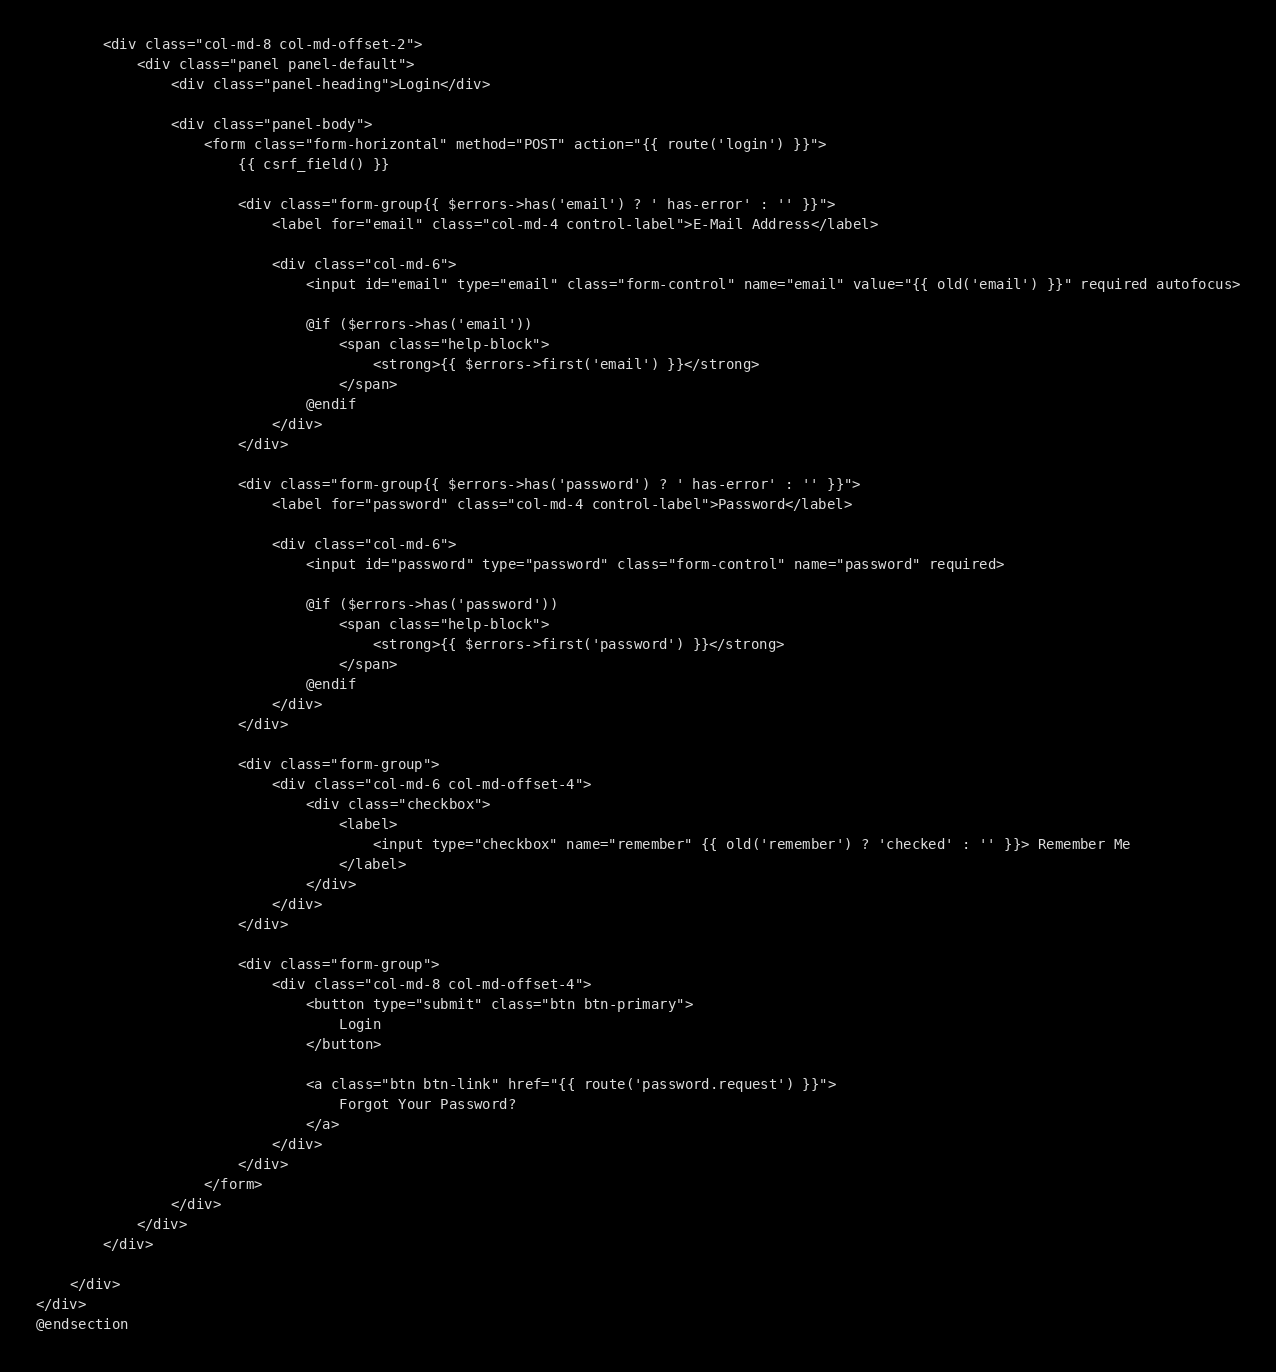Convert code to text. <code><loc_0><loc_0><loc_500><loc_500><_PHP_>        <div class="col-md-8 col-md-offset-2">
            <div class="panel panel-default">
                <div class="panel-heading">Login</div>

                <div class="panel-body">
                    <form class="form-horizontal" method="POST" action="{{ route('login') }}">
                        {{ csrf_field() }}

                        <div class="form-group{{ $errors->has('email') ? ' has-error' : '' }}">
                            <label for="email" class="col-md-4 control-label">E-Mail Address</label>

                            <div class="col-md-6">
                                <input id="email" type="email" class="form-control" name="email" value="{{ old('email') }}" required autofocus>

                                @if ($errors->has('email'))
                                    <span class="help-block">
                                        <strong>{{ $errors->first('email') }}</strong>
                                    </span>
                                @endif
                            </div>
                        </div>

                        <div class="form-group{{ $errors->has('password') ? ' has-error' : '' }}">
                            <label for="password" class="col-md-4 control-label">Password</label>

                            <div class="col-md-6">
                                <input id="password" type="password" class="form-control" name="password" required>

                                @if ($errors->has('password'))
                                    <span class="help-block">
                                        <strong>{{ $errors->first('password') }}</strong>
                                    </span>
                                @endif
                            </div>
                        </div>

                        <div class="form-group">
                            <div class="col-md-6 col-md-offset-4">
                                <div class="checkbox">
                                    <label>
                                        <input type="checkbox" name="remember" {{ old('remember') ? 'checked' : '' }}> Remember Me
                                    </label>
                                </div>
                            </div>
                        </div>

                        <div class="form-group">
                            <div class="col-md-8 col-md-offset-4">
                                <button type="submit" class="btn btn-primary">
                                    Login
                                </button>

                                <a class="btn btn-link" href="{{ route('password.request') }}">
                                    Forgot Your Password?
                                </a>
                            </div>
                        </div>
                    </form>
                </div>
            </div>
        </div>

    </div>
</div>
@endsection
</code> 